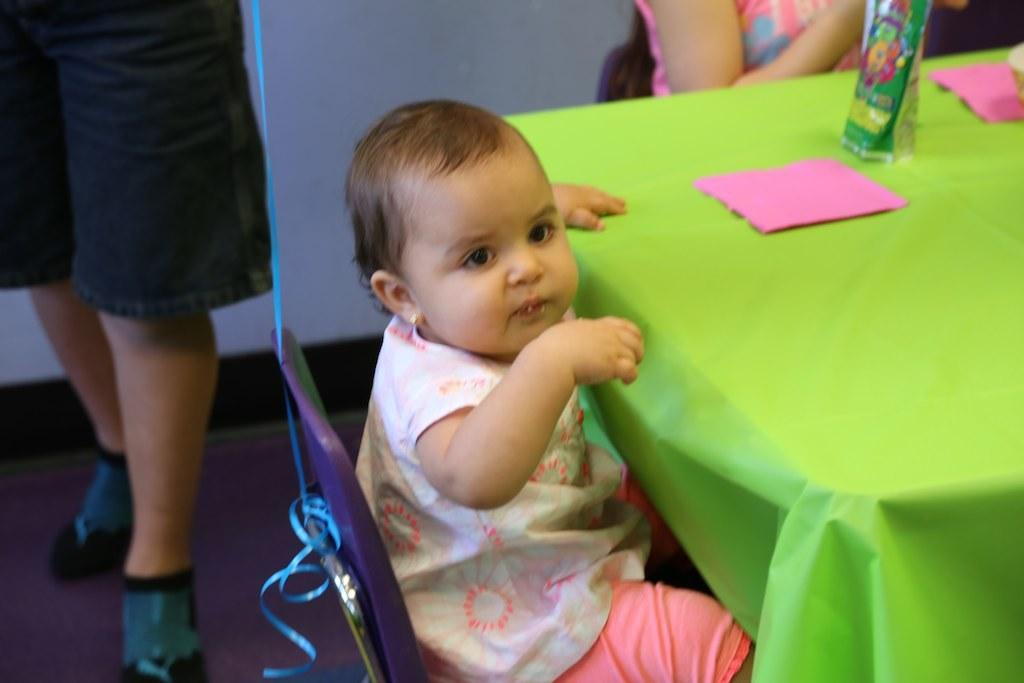What is the main subject of the image? The main subject of the image is a baby sitting on a chair. What is located in front of the chair? There is a table in front of the chair. What object is on the table? A vase is present on the table. Are there any other people visible in the image? Yes, there are other people visible in the image. What type of riddle is the baby trying to solve in the image? There is no riddle present in the image; the baby is simply sitting on a chair. 